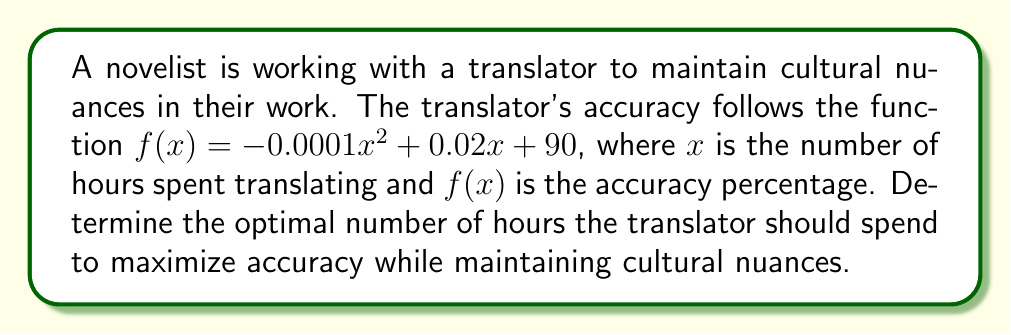Solve this math problem. To find the optimal number of hours for maximum accuracy, we need to find the maximum point of the given quadratic function.

1. The function is given as:
   $f(x) = -0.0001x^2 + 0.02x + 90$

2. To find the maximum point, we need to find the vertex of the parabola. For a quadratic function in the form $f(x) = ax^2 + bx + c$, the x-coordinate of the vertex is given by $x = -\frac{b}{2a}$.

3. In this case:
   $a = -0.0001$
   $b = 0.02$

4. Substituting these values:
   $x = -\frac{0.02}{2(-0.0001)} = \frac{0.02}{0.0002} = 100$

5. Therefore, the optimal number of hours is 100.

6. To find the maximum accuracy percentage, we substitute x = 100 into the original function:
   $f(100) = -0.0001(100)^2 + 0.02(100) + 90$
   $= -1 + 2 + 90 = 91$

So, the maximum accuracy percentage is 91%.
Answer: 100 hours; 91% accuracy 